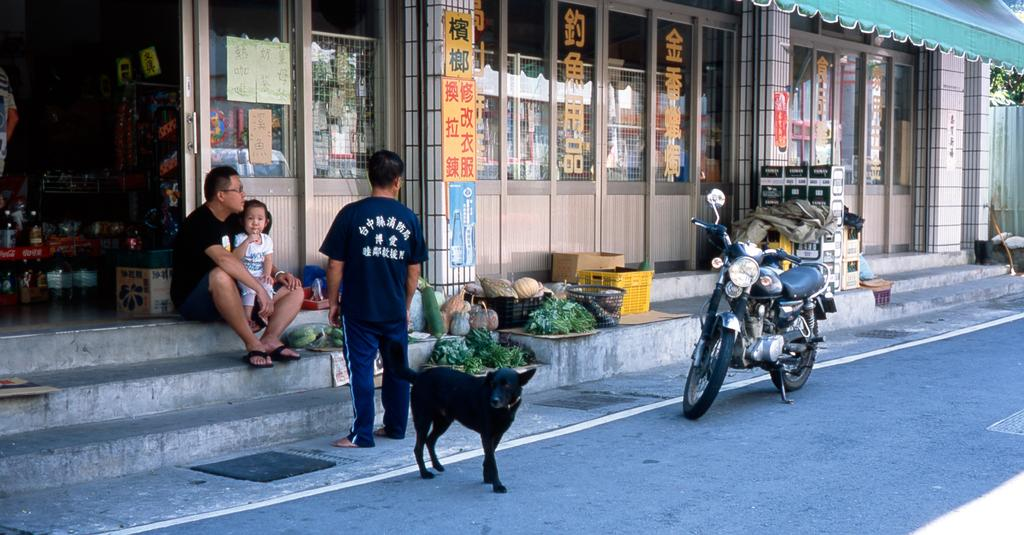How many people are present in the image? There are three people in the image. What type of animal can be seen in the image? There is a black color dog in the image. What type of food items are visible in the image? There are vegetables in the image. What structure is present in the image? There is a door in the image. What mode of transportation is visible in the image? There is a motorcycle in the image. What type of container is present in the image? There are baskets in the image. What type of man-made structures can be seen in the image? There are buildings in the image. Where are the stairs located in the image? The stairs are on the left side of the image. Can you tell me how many collars are on the dog in the image? There is no mention of a collar on the dog in the image, so it cannot be determined. Is there a beam supporting the buildings in the image? The image does not provide enough detail to determine if there is a beam supporting the buildings. What type of water body can be seen in the image? There is no water body, such as a river, present in the image. 